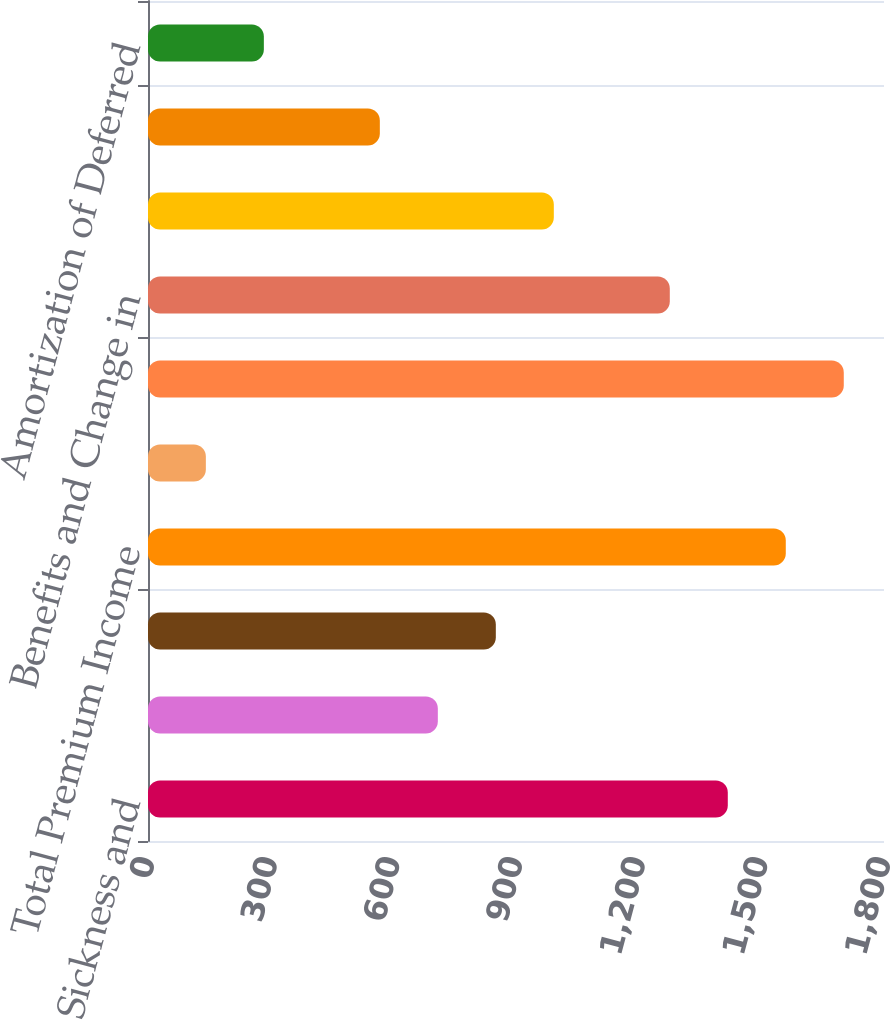Convert chart. <chart><loc_0><loc_0><loc_500><loc_500><bar_chart><fcel>Accident Sickness and<fcel>Life<fcel>Cancer and Critical Illness<fcel>Total Premium Income<fcel>Net Investment Income<fcel>Total<fcel>Benefits and Change in<fcel>Commissions<fcel>Deferral of Acquisition Costs<fcel>Amortization of Deferred<nl><fcel>1417.97<fcel>708.82<fcel>850.65<fcel>1559.8<fcel>141.5<fcel>1701.63<fcel>1276.14<fcel>992.48<fcel>566.99<fcel>283.33<nl></chart> 